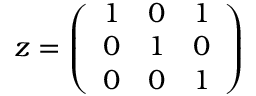<formula> <loc_0><loc_0><loc_500><loc_500>z = { \left ( \begin{array} { l l l } { 1 } & { 0 } & { 1 } \\ { 0 } & { 1 } & { 0 } \\ { 0 } & { 0 } & { 1 } \end{array} \right ) }</formula> 